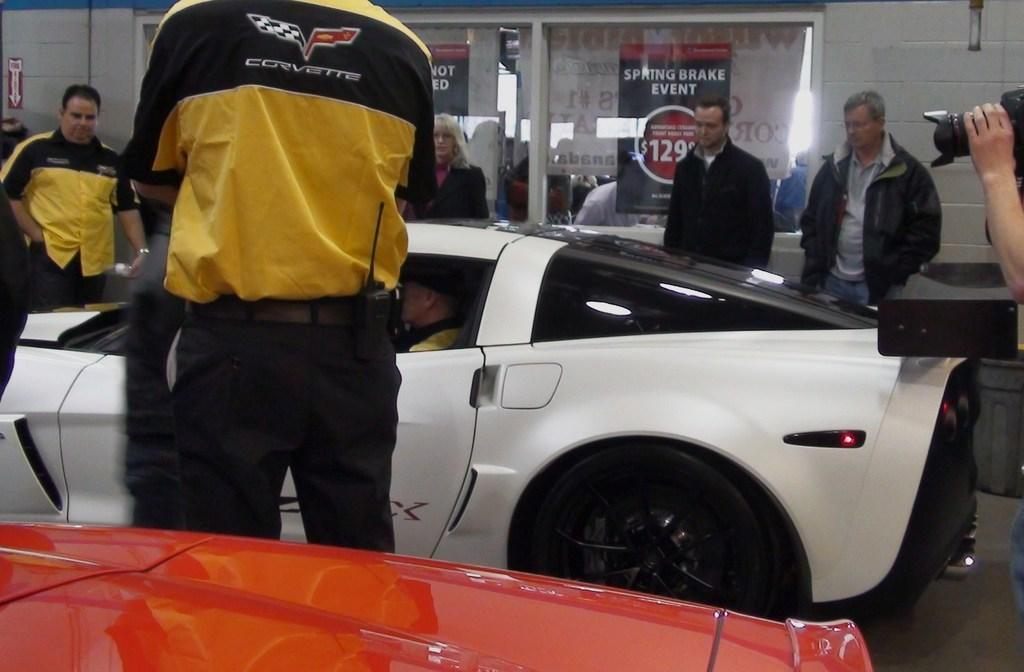What is happening in the image involving the car? There are people standing around a car in the image, and a man is sitting in the car. Can you describe the actions of the people in the image? The people are standing around the car, which suggests they might be observing or interacting with the car or the person sitting in it. Is there any indication of someone taking a photograph in the image? Yes, a person's hand is holding a camera in the image, which suggests that someone is taking a photograph. What type of circle is being used as a servant in the image? There is no circle or servant present in the image. Is the train visible in the image? No, there is no train visible in the image. 